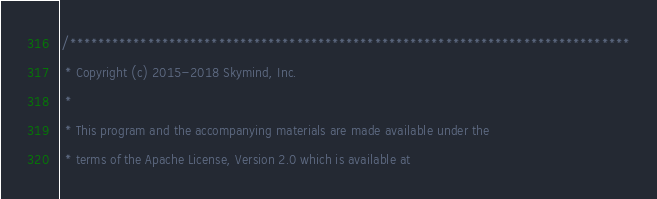Convert code to text. <code><loc_0><loc_0><loc_500><loc_500><_Cuda_>/*******************************************************************************
 * Copyright (c) 2015-2018 Skymind, Inc.
 *
 * This program and the accompanying materials are made available under the
 * terms of the Apache License, Version 2.0 which is available at</code> 